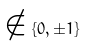<formula> <loc_0><loc_0><loc_500><loc_500>\notin \{ 0 , \pm 1 \}</formula> 